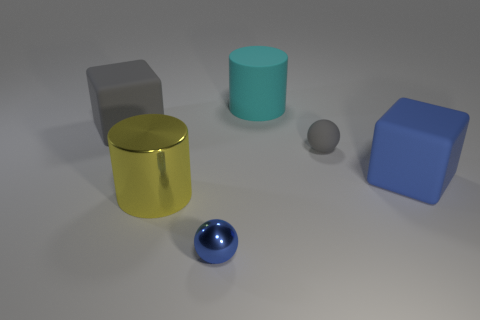Add 4 large brown spheres. How many objects exist? 10 Subtract all spheres. How many objects are left? 4 Subtract 2 balls. How many balls are left? 0 Subtract all gray cubes. How many cubes are left? 1 Subtract all green metal cylinders. Subtract all rubber objects. How many objects are left? 2 Add 1 blue metal things. How many blue metal things are left? 2 Add 4 large yellow shiny objects. How many large yellow shiny objects exist? 5 Subtract 0 brown blocks. How many objects are left? 6 Subtract all green balls. Subtract all red cylinders. How many balls are left? 2 